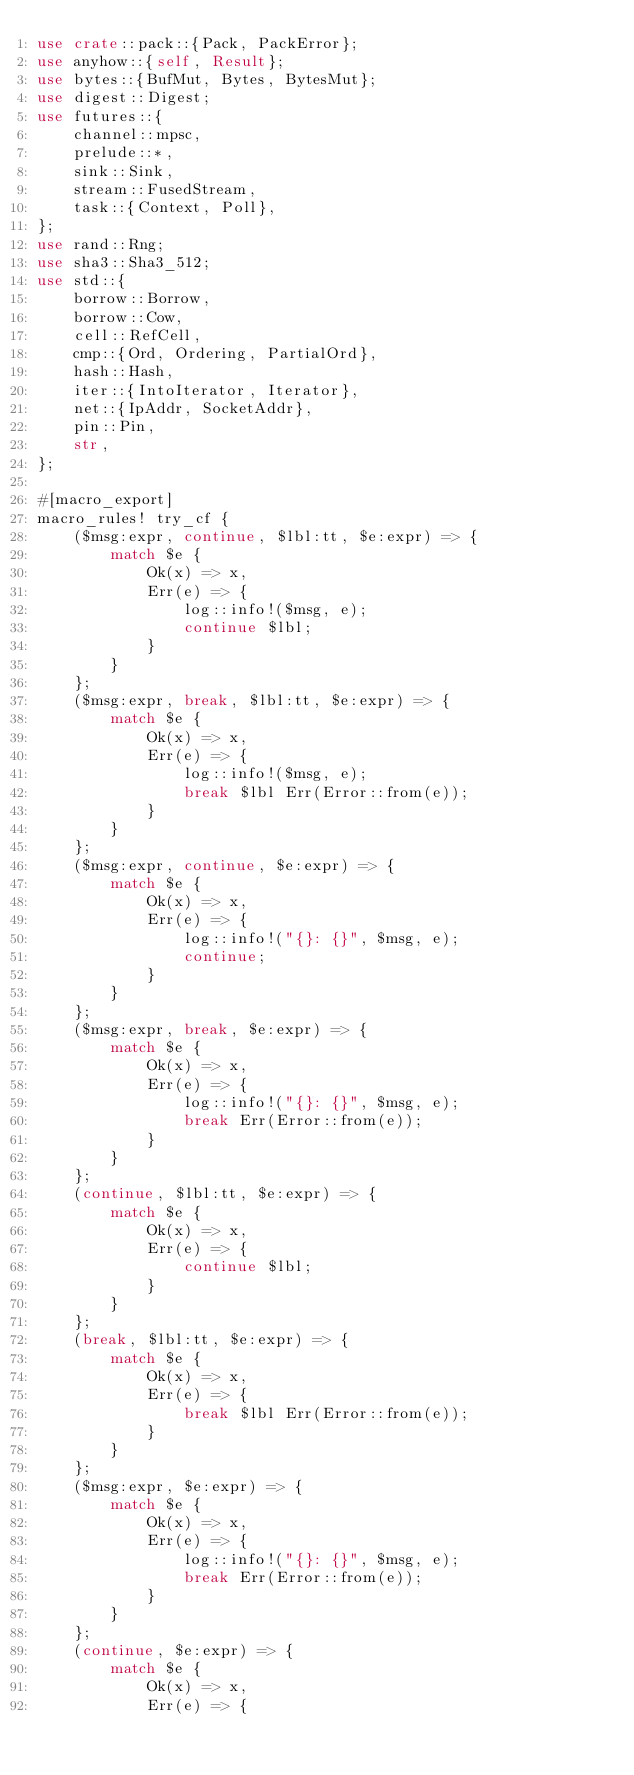<code> <loc_0><loc_0><loc_500><loc_500><_Rust_>use crate::pack::{Pack, PackError};
use anyhow::{self, Result};
use bytes::{BufMut, Bytes, BytesMut};
use digest::Digest;
use futures::{
    channel::mpsc,
    prelude::*,
    sink::Sink,
    stream::FusedStream,
    task::{Context, Poll},
};
use rand::Rng;
use sha3::Sha3_512;
use std::{
    borrow::Borrow,
    borrow::Cow,
    cell::RefCell,
    cmp::{Ord, Ordering, PartialOrd},
    hash::Hash,
    iter::{IntoIterator, Iterator},
    net::{IpAddr, SocketAddr},
    pin::Pin,
    str,
};

#[macro_export]
macro_rules! try_cf {
    ($msg:expr, continue, $lbl:tt, $e:expr) => {
        match $e {
            Ok(x) => x,
            Err(e) => {
                log::info!($msg, e);
                continue $lbl;
            }
        }
    };
    ($msg:expr, break, $lbl:tt, $e:expr) => {
        match $e {
            Ok(x) => x,
            Err(e) => {
                log::info!($msg, e);
                break $lbl Err(Error::from(e));
            }
        }
    };
    ($msg:expr, continue, $e:expr) => {
        match $e {
            Ok(x) => x,
            Err(e) => {
                log::info!("{}: {}", $msg, e);
                continue;
            }
        }
    };
    ($msg:expr, break, $e:expr) => {
        match $e {
            Ok(x) => x,
            Err(e) => {
                log::info!("{}: {}", $msg, e);
                break Err(Error::from(e));
            }
        }
    };
    (continue, $lbl:tt, $e:expr) => {
        match $e {
            Ok(x) => x,
            Err(e) => {
                continue $lbl;
            }
        }
    };
    (break, $lbl:tt, $e:expr) => {
        match $e {
            Ok(x) => x,
            Err(e) => {
                break $lbl Err(Error::from(e));
            }
        }
    };
    ($msg:expr, $e:expr) => {
        match $e {
            Ok(x) => x,
            Err(e) => {
                log::info!("{}: {}", $msg, e);
                break Err(Error::from(e));
            }
        }
    };
    (continue, $e:expr) => {
        match $e {
            Ok(x) => x,
            Err(e) => {</code> 